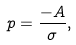<formula> <loc_0><loc_0><loc_500><loc_500>p = \frac { - A } { \sigma } ,</formula> 